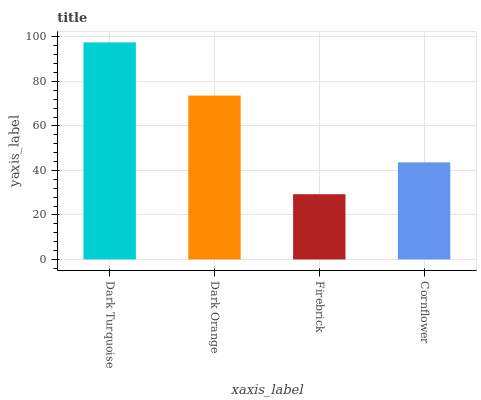Is Firebrick the minimum?
Answer yes or no. Yes. Is Dark Turquoise the maximum?
Answer yes or no. Yes. Is Dark Orange the minimum?
Answer yes or no. No. Is Dark Orange the maximum?
Answer yes or no. No. Is Dark Turquoise greater than Dark Orange?
Answer yes or no. Yes. Is Dark Orange less than Dark Turquoise?
Answer yes or no. Yes. Is Dark Orange greater than Dark Turquoise?
Answer yes or no. No. Is Dark Turquoise less than Dark Orange?
Answer yes or no. No. Is Dark Orange the high median?
Answer yes or no. Yes. Is Cornflower the low median?
Answer yes or no. Yes. Is Dark Turquoise the high median?
Answer yes or no. No. Is Dark Turquoise the low median?
Answer yes or no. No. 